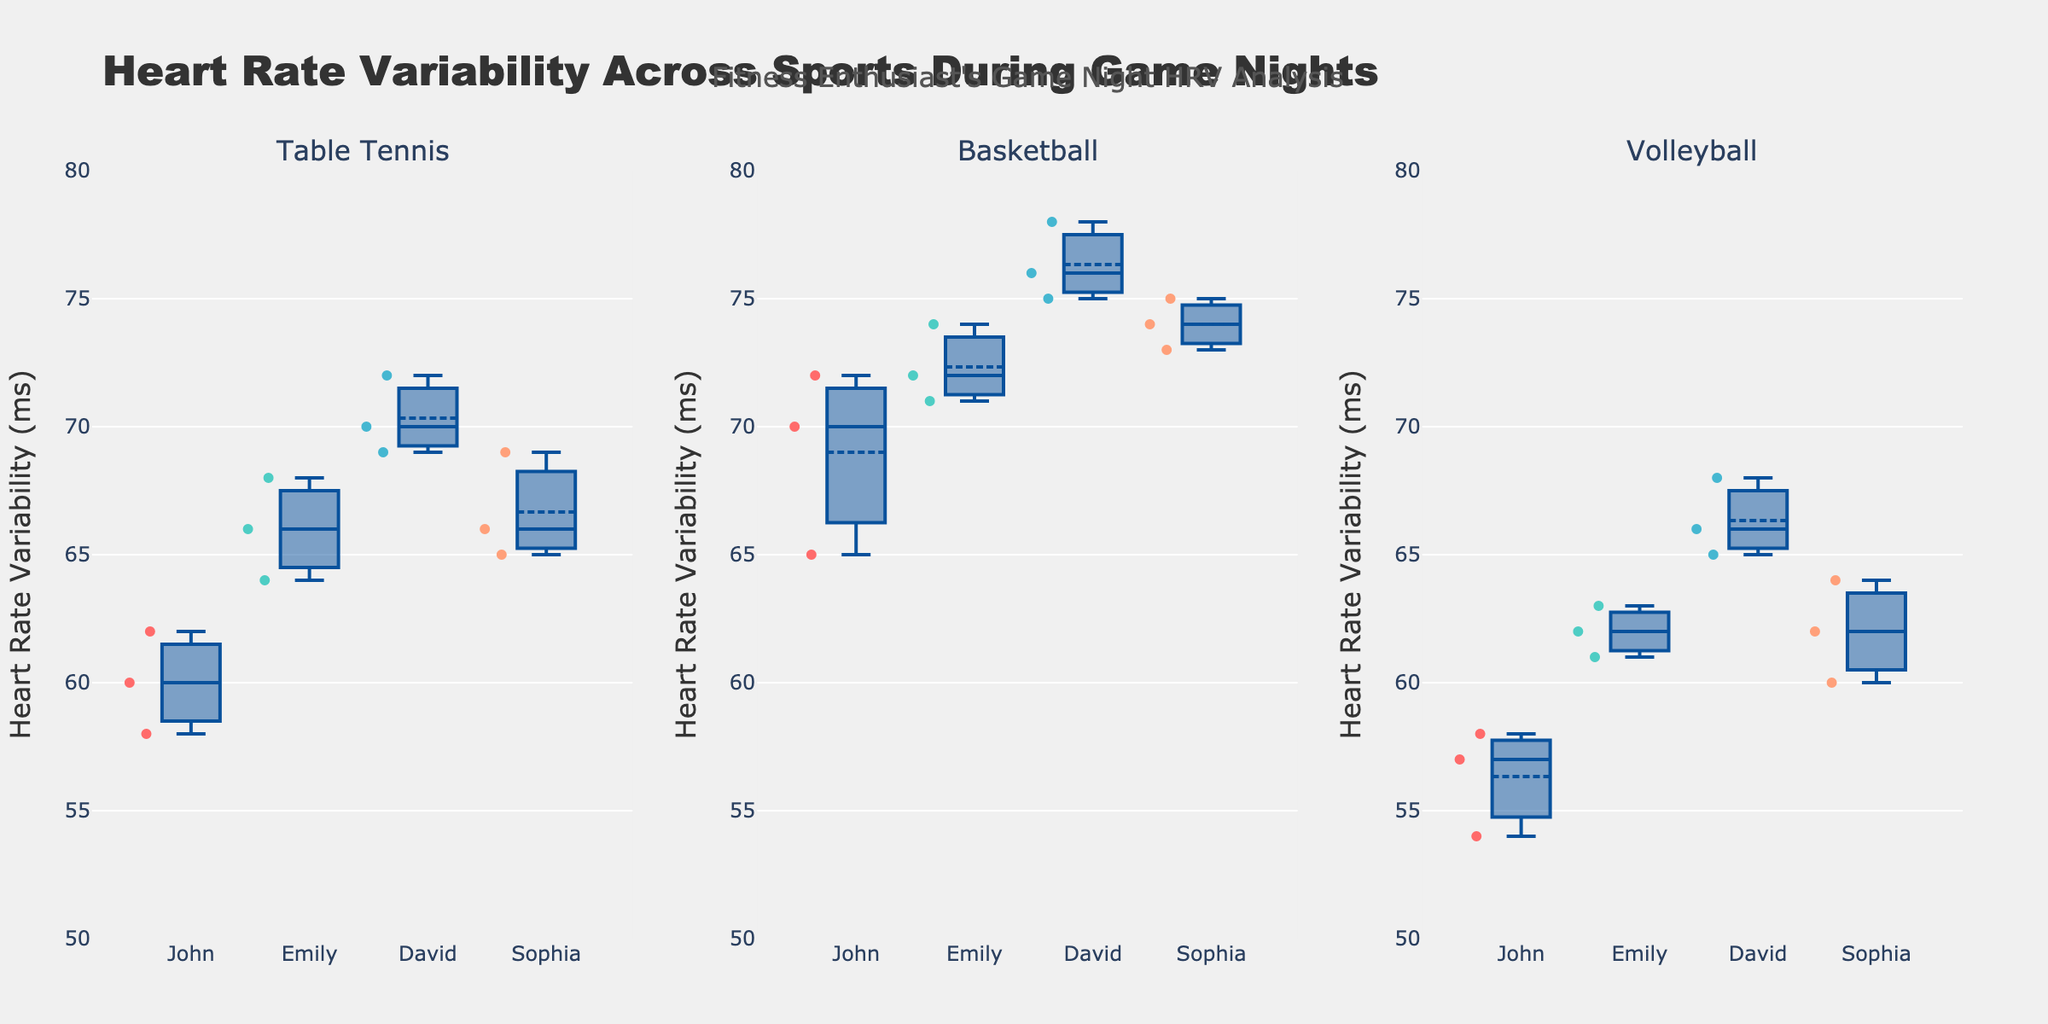What are the three sports analyzed in the figure? The titles of the three subplots indicate the sports analyzed: Table Tennis, Basketball, and Volleyball.
Answer: Table Tennis, Basketball, Volleyball How many athletes are there in each sport? Each subplot shows box plots for four athletes: John, Emily, David, and Sophia. We see separate box plots for each athlete in each sport subplot.
Answer: Four Which athlete has the highest HRV median for Basketball? By examining the median lines in the Basketball subplot, David's box plot has the highest median line.
Answer: David Which sport has the widest range of HRV values across all athletes? By observing the spread of the box plots in each subplot, Basketball shows the widest range of HRV values across all athletes with the maximum and minimum values.
Answer: Basketball What is the typical range of HRV values for Volleyball? Look at the interquartile range (IQR) of the box plots in the Volleyball subplot for all athletes. The IQR for Volleyball spans from the lower quartile around 60 to the upper quartile around 66.
Answer: 60-66 How does John's HRV median for Table Tennis compare to Emily's HRV median for Table Tennis? The median lines in John's and Emily's box plots for Table Tennis show that John's HRV median is lower than Emily's.
Answer: Lower Which sport has the highest overall HRV values among all athletes? By comparing the position of the box plots across all subplots, Basketball has higher HRV values overall compared to Table Tennis and Volleyball.
Answer: Basketball Is there an overlap in HRV ranges for Emily and David in Volleyball? Observe the box plot for Emily and David in the Volleyball subplot. Both box plots have overlapping ranges around 61-65
Answer: Yes What is the median HRV for Sophia in Table Tennis? The median line inside the box plot for Sophia in the Table Tennis subplot indicates a median HRV value around 66.
Answer: 66 Who is the athlete with the narrowest HRV range in Table Tennis? By examining the range from the lower to upper quartile in the Table Tennis subplot, Sophia has the narrowest HRV range.
Answer: Sophia 